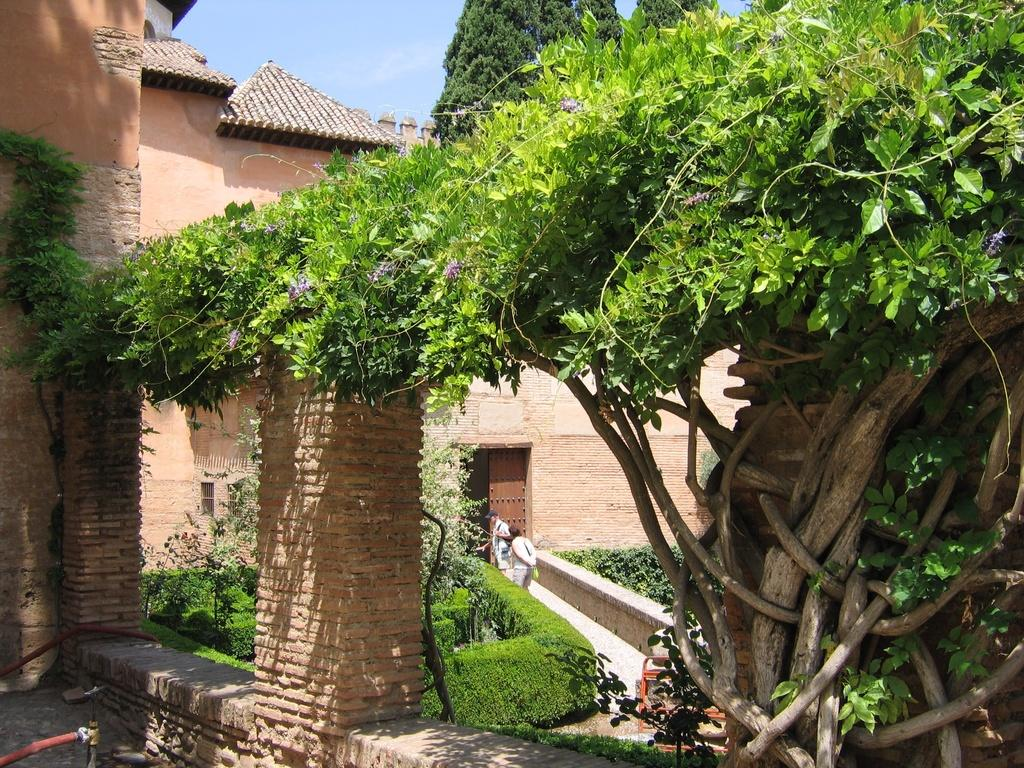How many people are standing on the path in the image? There are two people standing on the path in the image. What type of vegetation can be seen in the image? There are bushes and trees in the image. What other objects are present in the image? There are other objects in the image, but their specific details are not mentioned in the facts. What is the entrance to the building like in the image? There is a door visible on a building in the image. What can be seen on the building besides the door? There are a few things on the building, but their specific details are not mentioned in the facts. What is visible in the sky in the image? The sky is visible in the image, but its specific condition or appearance is not mentioned in the facts. Can you see any corn growing in the image? There is no corn present in the image; it features bushes and trees as vegetation. Is there a cave visible in the image? There is no cave present in the image; it features a door on a building and other objects. 